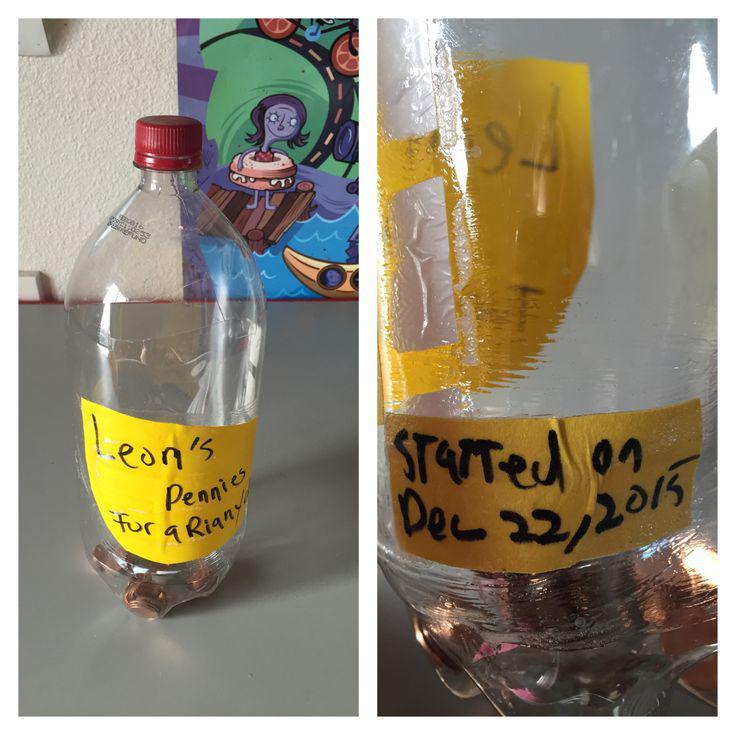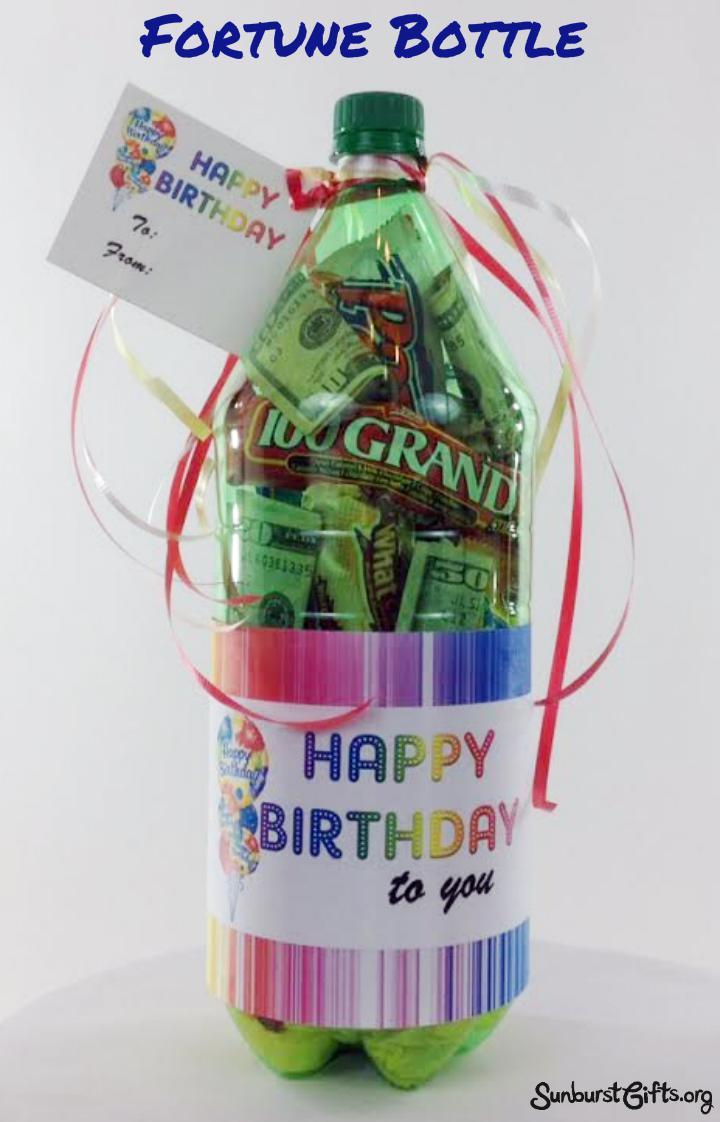The first image is the image on the left, the second image is the image on the right. Examine the images to the left and right. Is the description "Each image contains at least one green soda bottle, and the left image features a bottle with a label that includes jagged shapes and red letters." accurate? Answer yes or no. No. 